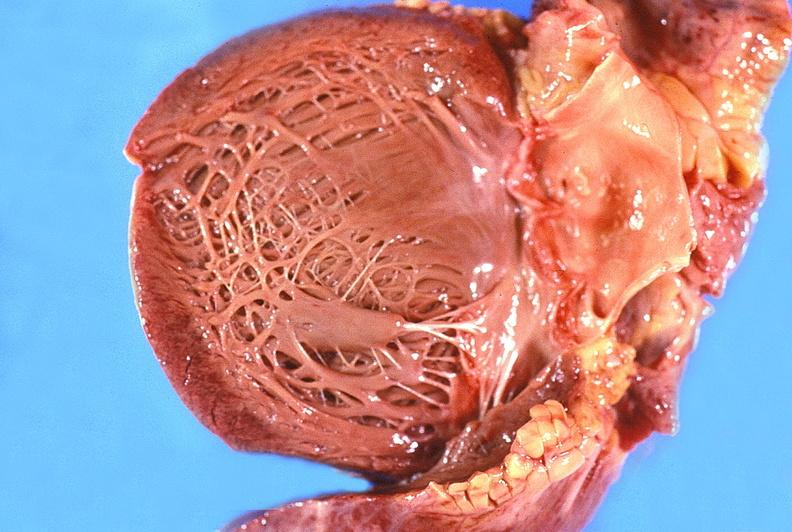what does this image show?
Answer the question using a single word or phrase. Normal aortic valve 